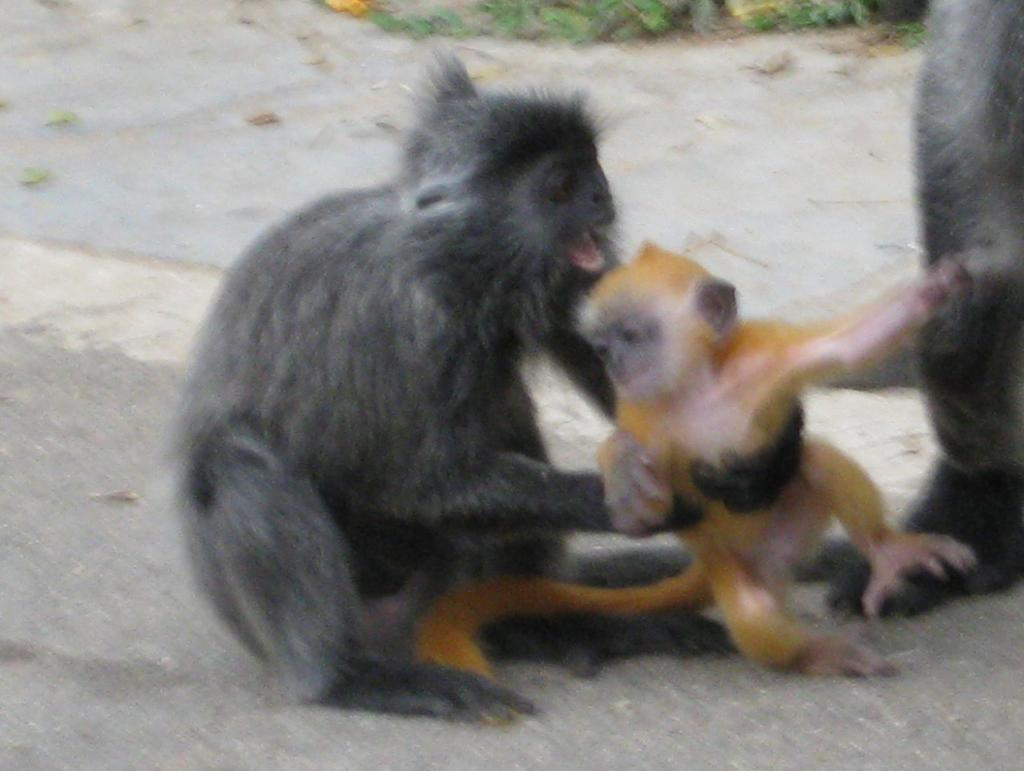What types of living organisms are present in the image? There are animals in the image. What colors are the animals in the image? The animals are in brown and cream colors. What can be seen in the background of the image? There are plants in the background of the image. What color are the plants in the image? The plants are in green color. What type of drink is being served in the image? There is no drink present in the image; it features animals and plants. How many houses can be seen in the image? There are no houses present in the image. 